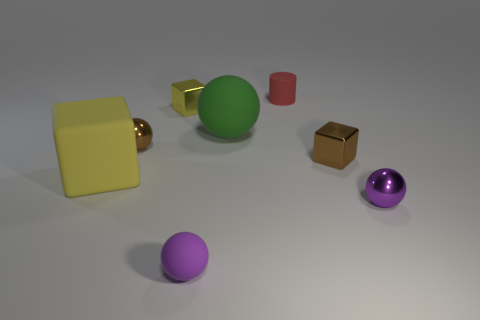What is the size of the metal sphere that is the same color as the tiny rubber sphere?
Your answer should be compact. Small. There is a brown thing that is the same shape as the purple shiny thing; what is its material?
Your response must be concise. Metal. There is a small object that is both in front of the big yellow block and to the left of the small purple shiny sphere; what is its shape?
Make the answer very short. Sphere. There is a large yellow thing that is the same material as the green object; what is its shape?
Keep it short and to the point. Cube. What is the material of the yellow cube behind the large cube?
Make the answer very short. Metal. Is the size of the brown shiny object left of the red thing the same as the matte sphere that is on the left side of the green matte object?
Your answer should be compact. Yes. What is the color of the cylinder?
Your response must be concise. Red. There is a large thing that is to the left of the tiny matte sphere; is its shape the same as the red rubber object?
Offer a very short reply. No. What material is the big green object?
Your response must be concise. Rubber. What shape is the yellow object that is the same size as the brown shiny ball?
Ensure brevity in your answer.  Cube. 